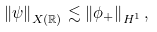<formula> <loc_0><loc_0><loc_500><loc_500>\left \| \psi \right \| _ { X ( \mathbb { R } ) } \lesssim \left \| \phi _ { + } \right \| _ { H ^ { 1 } } ,</formula> 